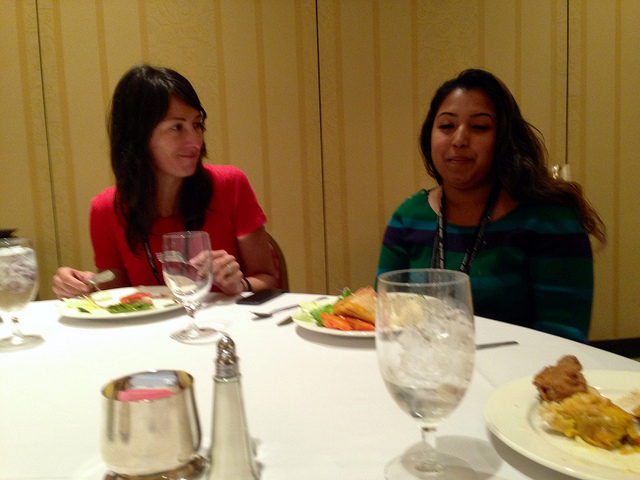<image>What soda is there? I am not sure about the soda in the image. It could be Sprite or none. What design is on the curtains? I am not sure what design is on the curtains, but it could possibly be stripes. What kind of wine is in the glasses? There is no wine in the glasses. It can be water. What soda is there? There is sprite in the image, but it can also be seen that there is no soda. What design is on the curtains? The design on the curtains is stripes. What kind of wine is in the glasses? It is not clear what kind of wine is in the glasses. It can be water or white wine. 